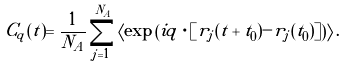<formula> <loc_0><loc_0><loc_500><loc_500>C _ { q } ( t ) = \frac { 1 } { N _ { A } } \sum _ { j = 1 } ^ { N _ { A } } \left \langle \exp \left ( i { q } \cdot [ { r } _ { j } ( t + t _ { 0 } ) - { r } _ { j } ( t _ { 0 } ) ] \right ) \right \rangle .</formula> 